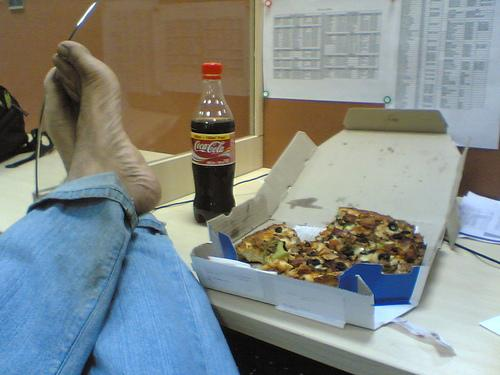What are the black things on the person's food?

Choices:
A) pepperonis
B) black olives
C) sausage
D) peppers black olives 